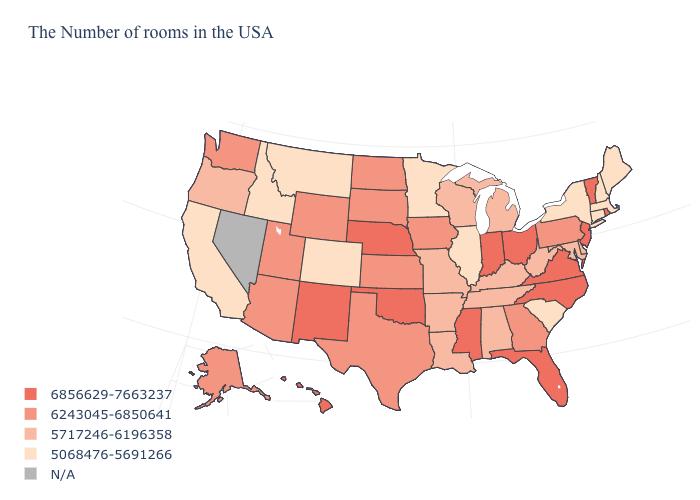What is the lowest value in states that border Wyoming?
Give a very brief answer. 5068476-5691266. What is the lowest value in the USA?
Answer briefly. 5068476-5691266. What is the value of Pennsylvania?
Keep it brief. 6243045-6850641. What is the highest value in the USA?
Be succinct. 6856629-7663237. What is the lowest value in states that border Illinois?
Concise answer only. 5717246-6196358. What is the lowest value in the MidWest?
Give a very brief answer. 5068476-5691266. Name the states that have a value in the range 6243045-6850641?
Quick response, please. Pennsylvania, Georgia, Iowa, Kansas, Texas, South Dakota, North Dakota, Wyoming, Utah, Arizona, Washington, Alaska. Name the states that have a value in the range N/A?
Give a very brief answer. Nevada. Which states have the lowest value in the South?
Give a very brief answer. South Carolina. Which states hav the highest value in the Northeast?
Give a very brief answer. Rhode Island, Vermont, New Jersey. Does the map have missing data?
Write a very short answer. Yes. Does North Carolina have the highest value in the USA?
Answer briefly. Yes. What is the value of Louisiana?
Be succinct. 5717246-6196358. Does Vermont have the highest value in the Northeast?
Write a very short answer. Yes. 